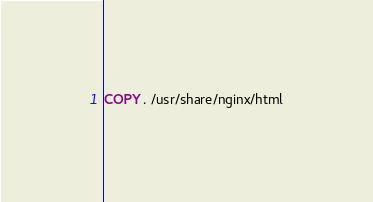Convert code to text. <code><loc_0><loc_0><loc_500><loc_500><_Dockerfile_>
COPY . /usr/share/nginx/html
</code> 